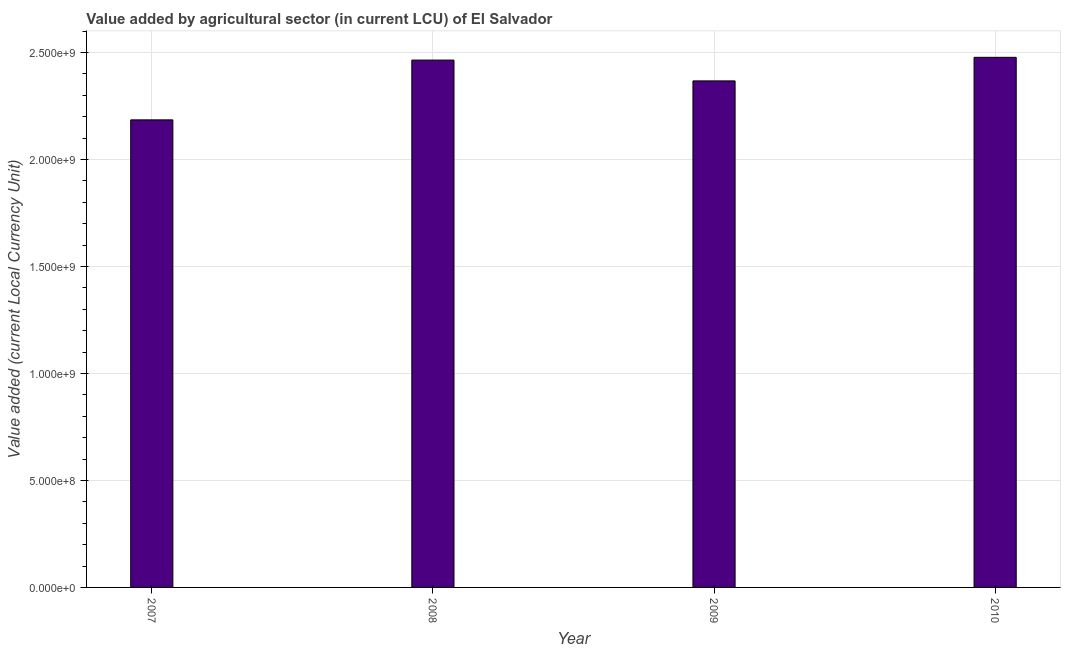Does the graph contain grids?
Your response must be concise. Yes. What is the title of the graph?
Your answer should be very brief. Value added by agricultural sector (in current LCU) of El Salvador. What is the label or title of the Y-axis?
Your answer should be compact. Value added (current Local Currency Unit). What is the value added by agriculture sector in 2010?
Provide a short and direct response. 2.48e+09. Across all years, what is the maximum value added by agriculture sector?
Offer a very short reply. 2.48e+09. Across all years, what is the minimum value added by agriculture sector?
Provide a short and direct response. 2.19e+09. In which year was the value added by agriculture sector maximum?
Give a very brief answer. 2010. What is the sum of the value added by agriculture sector?
Provide a short and direct response. 9.50e+09. What is the difference between the value added by agriculture sector in 2007 and 2008?
Your answer should be very brief. -2.79e+08. What is the average value added by agriculture sector per year?
Your answer should be compact. 2.37e+09. What is the median value added by agriculture sector?
Your answer should be very brief. 2.42e+09. Do a majority of the years between 2008 and 2009 (inclusive) have value added by agriculture sector greater than 1200000000 LCU?
Your answer should be compact. Yes. What is the ratio of the value added by agriculture sector in 2007 to that in 2008?
Provide a succinct answer. 0.89. Is the value added by agriculture sector in 2008 less than that in 2009?
Give a very brief answer. No. Is the difference between the value added by agriculture sector in 2008 and 2010 greater than the difference between any two years?
Provide a succinct answer. No. What is the difference between the highest and the second highest value added by agriculture sector?
Your answer should be very brief. 1.29e+07. What is the difference between the highest and the lowest value added by agriculture sector?
Provide a succinct answer. 2.92e+08. What is the difference between two consecutive major ticks on the Y-axis?
Offer a very short reply. 5.00e+08. What is the Value added (current Local Currency Unit) of 2007?
Make the answer very short. 2.19e+09. What is the Value added (current Local Currency Unit) of 2008?
Provide a succinct answer. 2.46e+09. What is the Value added (current Local Currency Unit) in 2009?
Ensure brevity in your answer.  2.37e+09. What is the Value added (current Local Currency Unit) in 2010?
Provide a succinct answer. 2.48e+09. What is the difference between the Value added (current Local Currency Unit) in 2007 and 2008?
Make the answer very short. -2.79e+08. What is the difference between the Value added (current Local Currency Unit) in 2007 and 2009?
Ensure brevity in your answer.  -1.82e+08. What is the difference between the Value added (current Local Currency Unit) in 2007 and 2010?
Keep it short and to the point. -2.92e+08. What is the difference between the Value added (current Local Currency Unit) in 2008 and 2009?
Offer a very short reply. 9.73e+07. What is the difference between the Value added (current Local Currency Unit) in 2008 and 2010?
Give a very brief answer. -1.29e+07. What is the difference between the Value added (current Local Currency Unit) in 2009 and 2010?
Your answer should be compact. -1.10e+08. What is the ratio of the Value added (current Local Currency Unit) in 2007 to that in 2008?
Ensure brevity in your answer.  0.89. What is the ratio of the Value added (current Local Currency Unit) in 2007 to that in 2009?
Offer a very short reply. 0.92. What is the ratio of the Value added (current Local Currency Unit) in 2007 to that in 2010?
Provide a succinct answer. 0.88. What is the ratio of the Value added (current Local Currency Unit) in 2008 to that in 2009?
Your response must be concise. 1.04. What is the ratio of the Value added (current Local Currency Unit) in 2008 to that in 2010?
Ensure brevity in your answer.  0.99. What is the ratio of the Value added (current Local Currency Unit) in 2009 to that in 2010?
Your answer should be very brief. 0.96. 